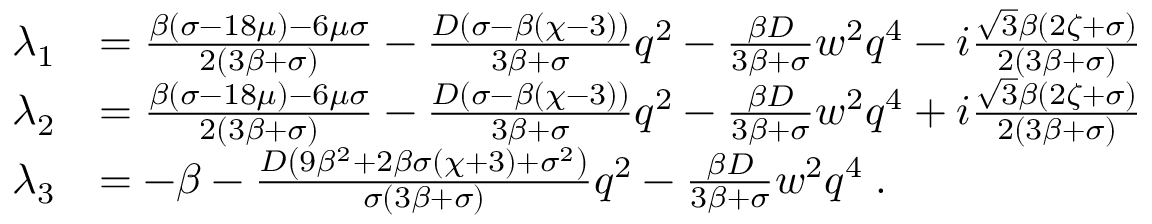<formula> <loc_0><loc_0><loc_500><loc_500>\begin{array} { r l } { \lambda _ { 1 } } & { = \frac { \beta ( \sigma - 1 8 \mu ) - 6 \mu \sigma } { 2 ( 3 \beta + \sigma ) } - \frac { D ( \sigma - \beta ( \chi - 3 ) ) } { 3 \beta + \sigma } q ^ { 2 } - \frac { \beta D } { 3 \beta + \sigma } w ^ { 2 } q ^ { 4 } - i \frac { \sqrt { 3 } \beta ( 2 \zeta + \sigma ) } { 2 ( 3 \beta + \sigma ) } } \\ { \lambda _ { 2 } } & { = \frac { \beta ( \sigma - 1 8 \mu ) - 6 \mu \sigma } { 2 ( 3 \beta + \sigma ) } - \frac { D ( \sigma - \beta ( \chi - 3 ) ) } { 3 \beta + \sigma } q ^ { 2 } - \frac { \beta D } { 3 \beta + \sigma } w ^ { 2 } q ^ { 4 } + i \frac { \sqrt { 3 } \beta ( 2 \zeta + \sigma ) } { 2 ( 3 \beta + \sigma ) } } \\ { \lambda _ { 3 } } & { = - \beta - \frac { D \left ( 9 \beta ^ { 2 } + 2 \beta \sigma ( \chi + 3 ) + \sigma ^ { 2 } \right ) } { \sigma ( 3 \beta + \sigma ) } q ^ { 2 } - \frac { \beta D } { 3 \beta + \sigma } w ^ { 2 } q ^ { 4 } \, . } \end{array}</formula> 